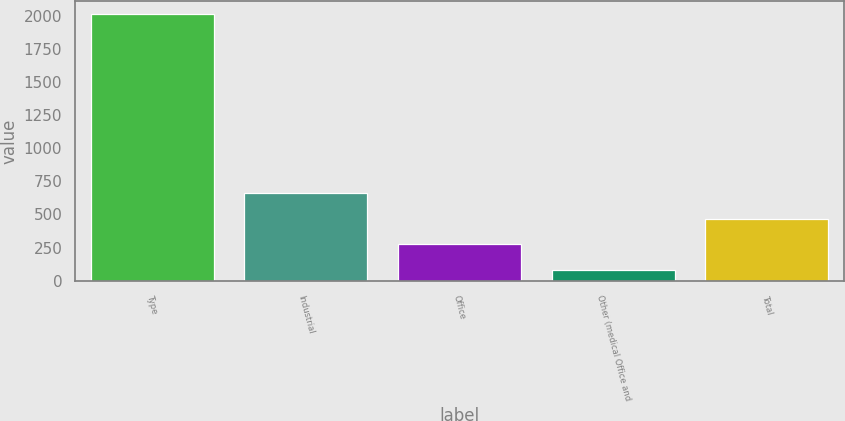Convert chart to OTSL. <chart><loc_0><loc_0><loc_500><loc_500><bar_chart><fcel>Type<fcel>Industrial<fcel>Office<fcel>Other (medical Office and<fcel>Total<nl><fcel>2009<fcel>660.8<fcel>275.6<fcel>83<fcel>468.2<nl></chart> 